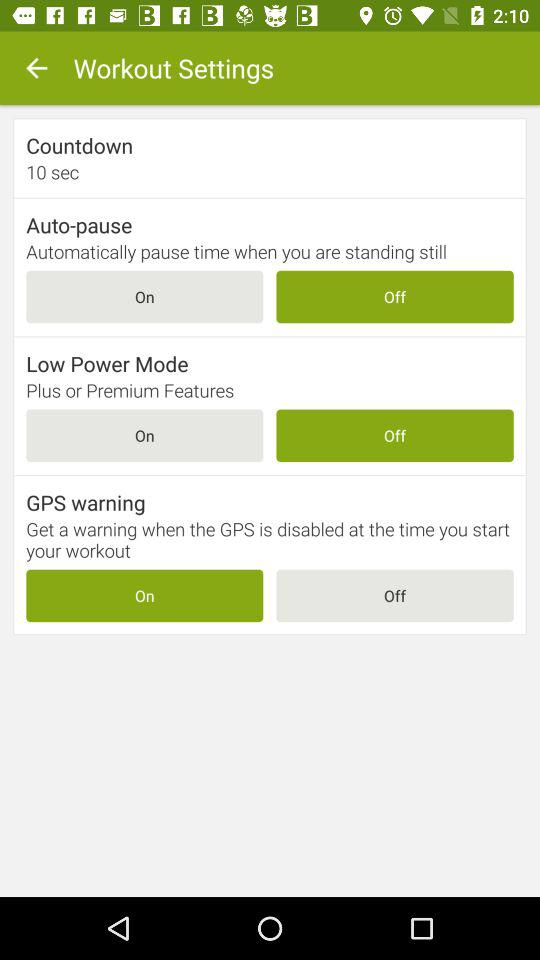How many seconds is the "Countdown"? There are "10 seconds" in the countdown. 